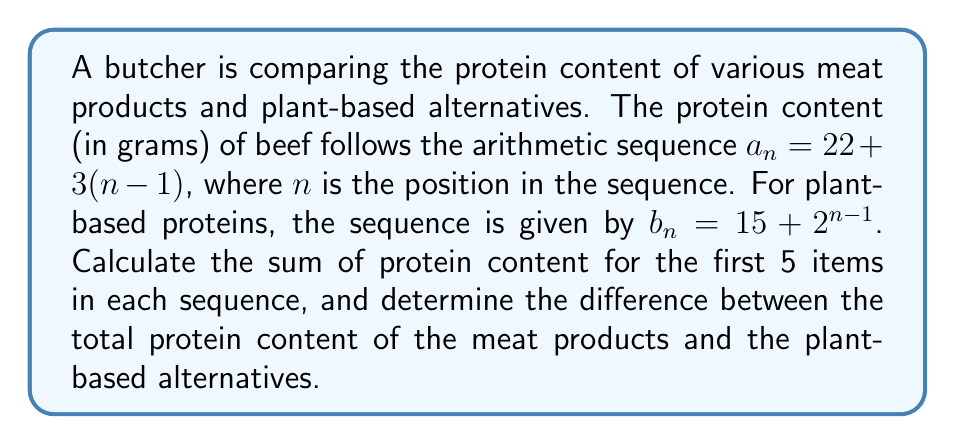Can you answer this question? 1. For the beef sequence $a_n = 22 + 3(n-1)$:
   First 5 terms: $a_1 = 22$, $a_2 = 25$, $a_3 = 28$, $a_4 = 31$, $a_5 = 34$

   Sum of arithmetic sequence: $S_n = \frac{n}{2}(a_1 + a_n)$
   $S_5 = \frac{5}{2}(22 + 34) = \frac{5}{2}(56) = 140$

2. For the plant-based sequence $b_n = 15 + 2^{n-1}$:
   First 5 terms: $b_1 = 16$, $b_2 = 17$, $b_3 = 19$, $b_4 = 23$, $b_5 = 31$

   Sum: $S_5 = 16 + 17 + 19 + 23 + 31 = 106$

3. Difference between total protein content:
   $140 - 106 = 34$
Answer: 34 grams 